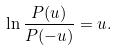<formula> <loc_0><loc_0><loc_500><loc_500>\ln \frac { P ( u ) } { P ( - u ) } = u .</formula> 